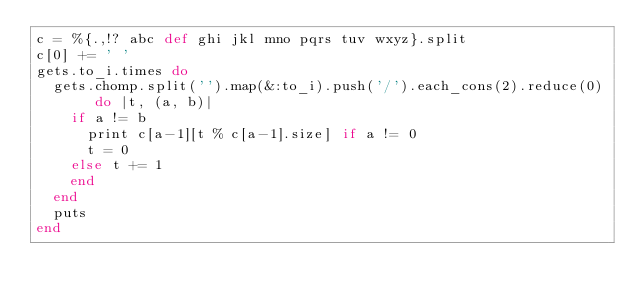Convert code to text. <code><loc_0><loc_0><loc_500><loc_500><_Ruby_>c = %{.,!? abc def ghi jkl mno pqrs tuv wxyz}.split
c[0] += ' '
gets.to_i.times do
  gets.chomp.split('').map(&:to_i).push('/').each_cons(2).reduce(0) do |t, (a, b)|
    if a != b
      print c[a-1][t % c[a-1].size] if a != 0
      t = 0
    else t += 1
    end
  end
  puts
end</code> 